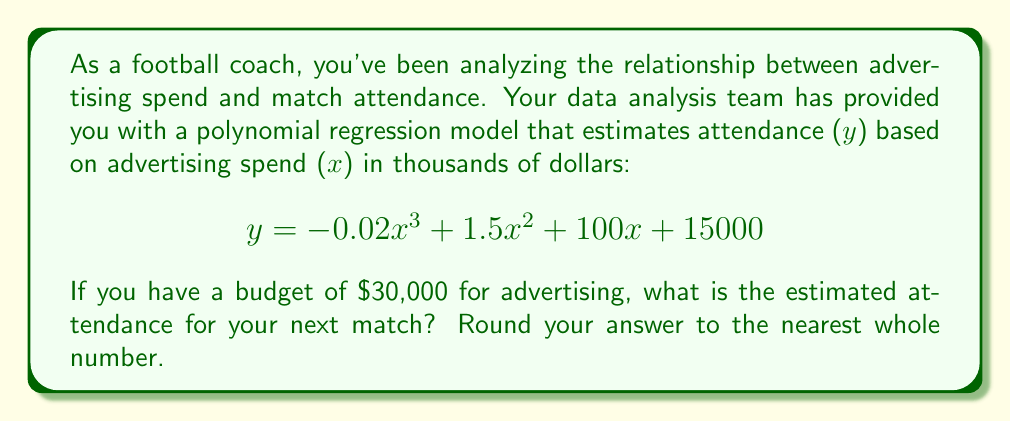Solve this math problem. To solve this problem, we need to substitute the advertising spend into the given polynomial equation and calculate the result. Here's the step-by-step process:

1. Given equation: $y = -0.02x^3 + 1.5x^2 + 100x + 15000$
2. Advertising spend: $30,000 = 30$ thousand dollars
3. Substitute $x = 30$ into the equation:

   $y = -0.02(30)^3 + 1.5(30)^2 + 100(30) + 15000$

4. Simplify the equation:
   
   $y = -0.02(27000) + 1.5(900) + 3000 + 15000$
   
   $y = -540 + 1350 + 3000 + 15000$

5. Calculate the final result:
   
   $y = 18810$

6. Round to the nearest whole number: 18,810

Therefore, the estimated attendance for the next match with an advertising spend of $30,000 is 18,810 people.
Answer: 18,810 